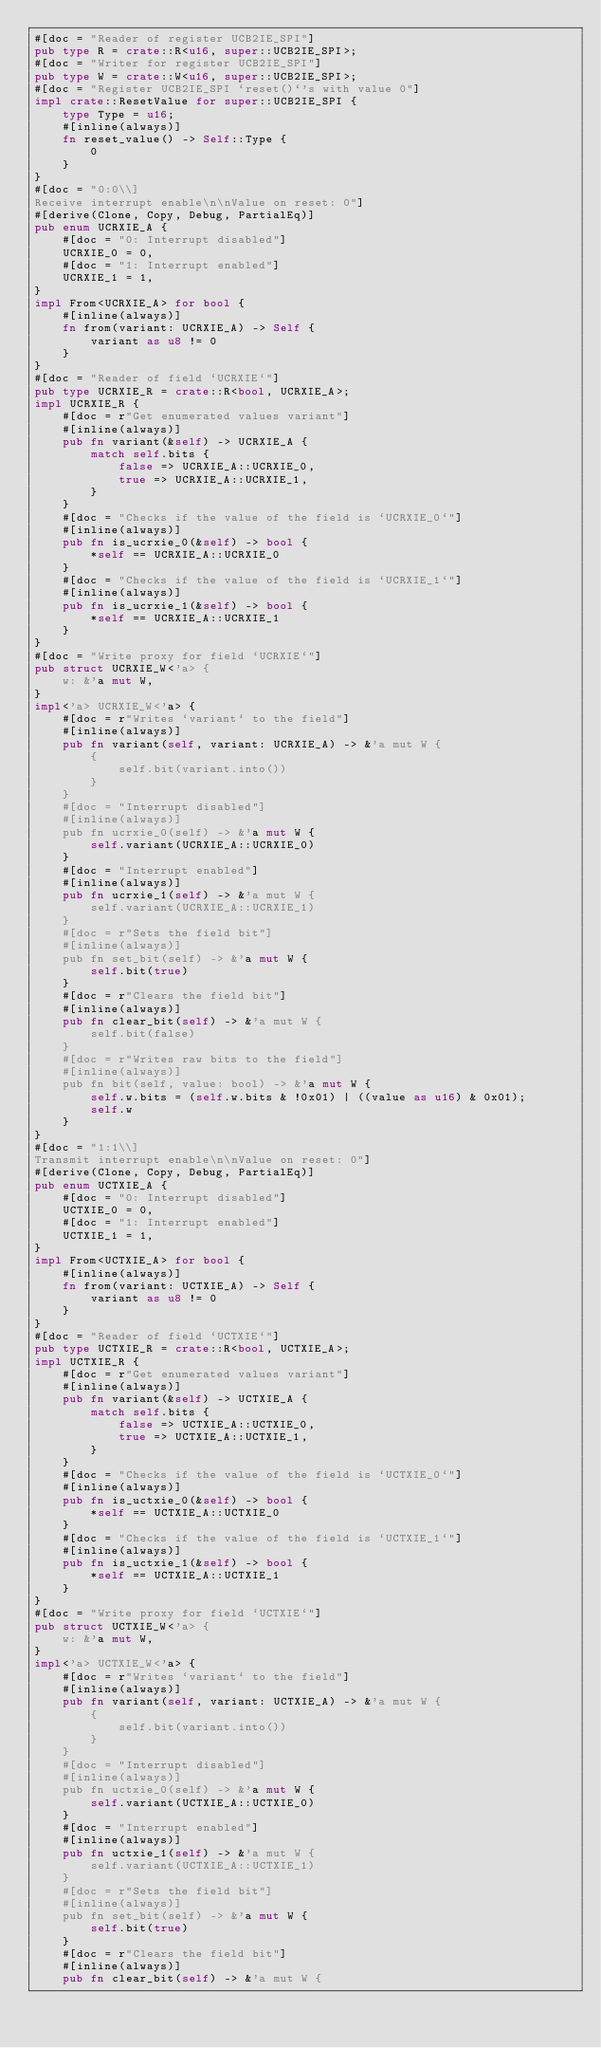Convert code to text. <code><loc_0><loc_0><loc_500><loc_500><_Rust_>#[doc = "Reader of register UCB2IE_SPI"]
pub type R = crate::R<u16, super::UCB2IE_SPI>;
#[doc = "Writer for register UCB2IE_SPI"]
pub type W = crate::W<u16, super::UCB2IE_SPI>;
#[doc = "Register UCB2IE_SPI `reset()`'s with value 0"]
impl crate::ResetValue for super::UCB2IE_SPI {
    type Type = u16;
    #[inline(always)]
    fn reset_value() -> Self::Type {
        0
    }
}
#[doc = "0:0\\]
Receive interrupt enable\n\nValue on reset: 0"]
#[derive(Clone, Copy, Debug, PartialEq)]
pub enum UCRXIE_A {
    #[doc = "0: Interrupt disabled"]
    UCRXIE_0 = 0,
    #[doc = "1: Interrupt enabled"]
    UCRXIE_1 = 1,
}
impl From<UCRXIE_A> for bool {
    #[inline(always)]
    fn from(variant: UCRXIE_A) -> Self {
        variant as u8 != 0
    }
}
#[doc = "Reader of field `UCRXIE`"]
pub type UCRXIE_R = crate::R<bool, UCRXIE_A>;
impl UCRXIE_R {
    #[doc = r"Get enumerated values variant"]
    #[inline(always)]
    pub fn variant(&self) -> UCRXIE_A {
        match self.bits {
            false => UCRXIE_A::UCRXIE_0,
            true => UCRXIE_A::UCRXIE_1,
        }
    }
    #[doc = "Checks if the value of the field is `UCRXIE_0`"]
    #[inline(always)]
    pub fn is_ucrxie_0(&self) -> bool {
        *self == UCRXIE_A::UCRXIE_0
    }
    #[doc = "Checks if the value of the field is `UCRXIE_1`"]
    #[inline(always)]
    pub fn is_ucrxie_1(&self) -> bool {
        *self == UCRXIE_A::UCRXIE_1
    }
}
#[doc = "Write proxy for field `UCRXIE`"]
pub struct UCRXIE_W<'a> {
    w: &'a mut W,
}
impl<'a> UCRXIE_W<'a> {
    #[doc = r"Writes `variant` to the field"]
    #[inline(always)]
    pub fn variant(self, variant: UCRXIE_A) -> &'a mut W {
        {
            self.bit(variant.into())
        }
    }
    #[doc = "Interrupt disabled"]
    #[inline(always)]
    pub fn ucrxie_0(self) -> &'a mut W {
        self.variant(UCRXIE_A::UCRXIE_0)
    }
    #[doc = "Interrupt enabled"]
    #[inline(always)]
    pub fn ucrxie_1(self) -> &'a mut W {
        self.variant(UCRXIE_A::UCRXIE_1)
    }
    #[doc = r"Sets the field bit"]
    #[inline(always)]
    pub fn set_bit(self) -> &'a mut W {
        self.bit(true)
    }
    #[doc = r"Clears the field bit"]
    #[inline(always)]
    pub fn clear_bit(self) -> &'a mut W {
        self.bit(false)
    }
    #[doc = r"Writes raw bits to the field"]
    #[inline(always)]
    pub fn bit(self, value: bool) -> &'a mut W {
        self.w.bits = (self.w.bits & !0x01) | ((value as u16) & 0x01);
        self.w
    }
}
#[doc = "1:1\\]
Transmit interrupt enable\n\nValue on reset: 0"]
#[derive(Clone, Copy, Debug, PartialEq)]
pub enum UCTXIE_A {
    #[doc = "0: Interrupt disabled"]
    UCTXIE_0 = 0,
    #[doc = "1: Interrupt enabled"]
    UCTXIE_1 = 1,
}
impl From<UCTXIE_A> for bool {
    #[inline(always)]
    fn from(variant: UCTXIE_A) -> Self {
        variant as u8 != 0
    }
}
#[doc = "Reader of field `UCTXIE`"]
pub type UCTXIE_R = crate::R<bool, UCTXIE_A>;
impl UCTXIE_R {
    #[doc = r"Get enumerated values variant"]
    #[inline(always)]
    pub fn variant(&self) -> UCTXIE_A {
        match self.bits {
            false => UCTXIE_A::UCTXIE_0,
            true => UCTXIE_A::UCTXIE_1,
        }
    }
    #[doc = "Checks if the value of the field is `UCTXIE_0`"]
    #[inline(always)]
    pub fn is_uctxie_0(&self) -> bool {
        *self == UCTXIE_A::UCTXIE_0
    }
    #[doc = "Checks if the value of the field is `UCTXIE_1`"]
    #[inline(always)]
    pub fn is_uctxie_1(&self) -> bool {
        *self == UCTXIE_A::UCTXIE_1
    }
}
#[doc = "Write proxy for field `UCTXIE`"]
pub struct UCTXIE_W<'a> {
    w: &'a mut W,
}
impl<'a> UCTXIE_W<'a> {
    #[doc = r"Writes `variant` to the field"]
    #[inline(always)]
    pub fn variant(self, variant: UCTXIE_A) -> &'a mut W {
        {
            self.bit(variant.into())
        }
    }
    #[doc = "Interrupt disabled"]
    #[inline(always)]
    pub fn uctxie_0(self) -> &'a mut W {
        self.variant(UCTXIE_A::UCTXIE_0)
    }
    #[doc = "Interrupt enabled"]
    #[inline(always)]
    pub fn uctxie_1(self) -> &'a mut W {
        self.variant(UCTXIE_A::UCTXIE_1)
    }
    #[doc = r"Sets the field bit"]
    #[inline(always)]
    pub fn set_bit(self) -> &'a mut W {
        self.bit(true)
    }
    #[doc = r"Clears the field bit"]
    #[inline(always)]
    pub fn clear_bit(self) -> &'a mut W {</code> 